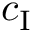Convert formula to latex. <formula><loc_0><loc_0><loc_500><loc_500>c _ { I }</formula> 